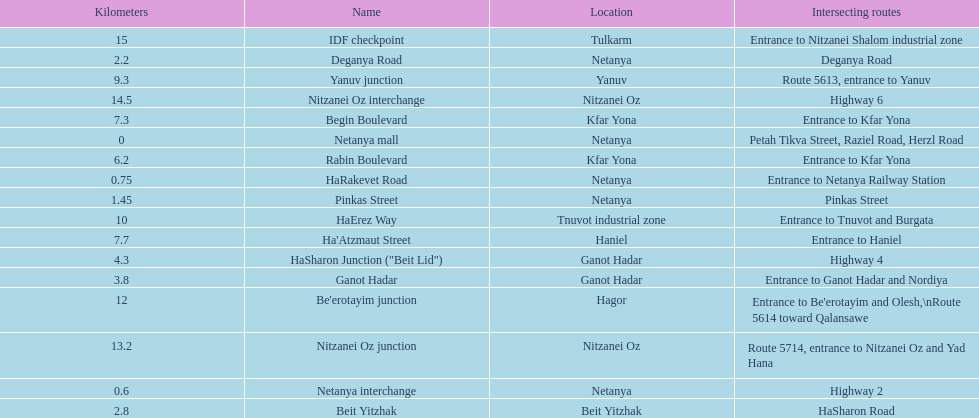How many portions are lo?cated in netanya 5. 